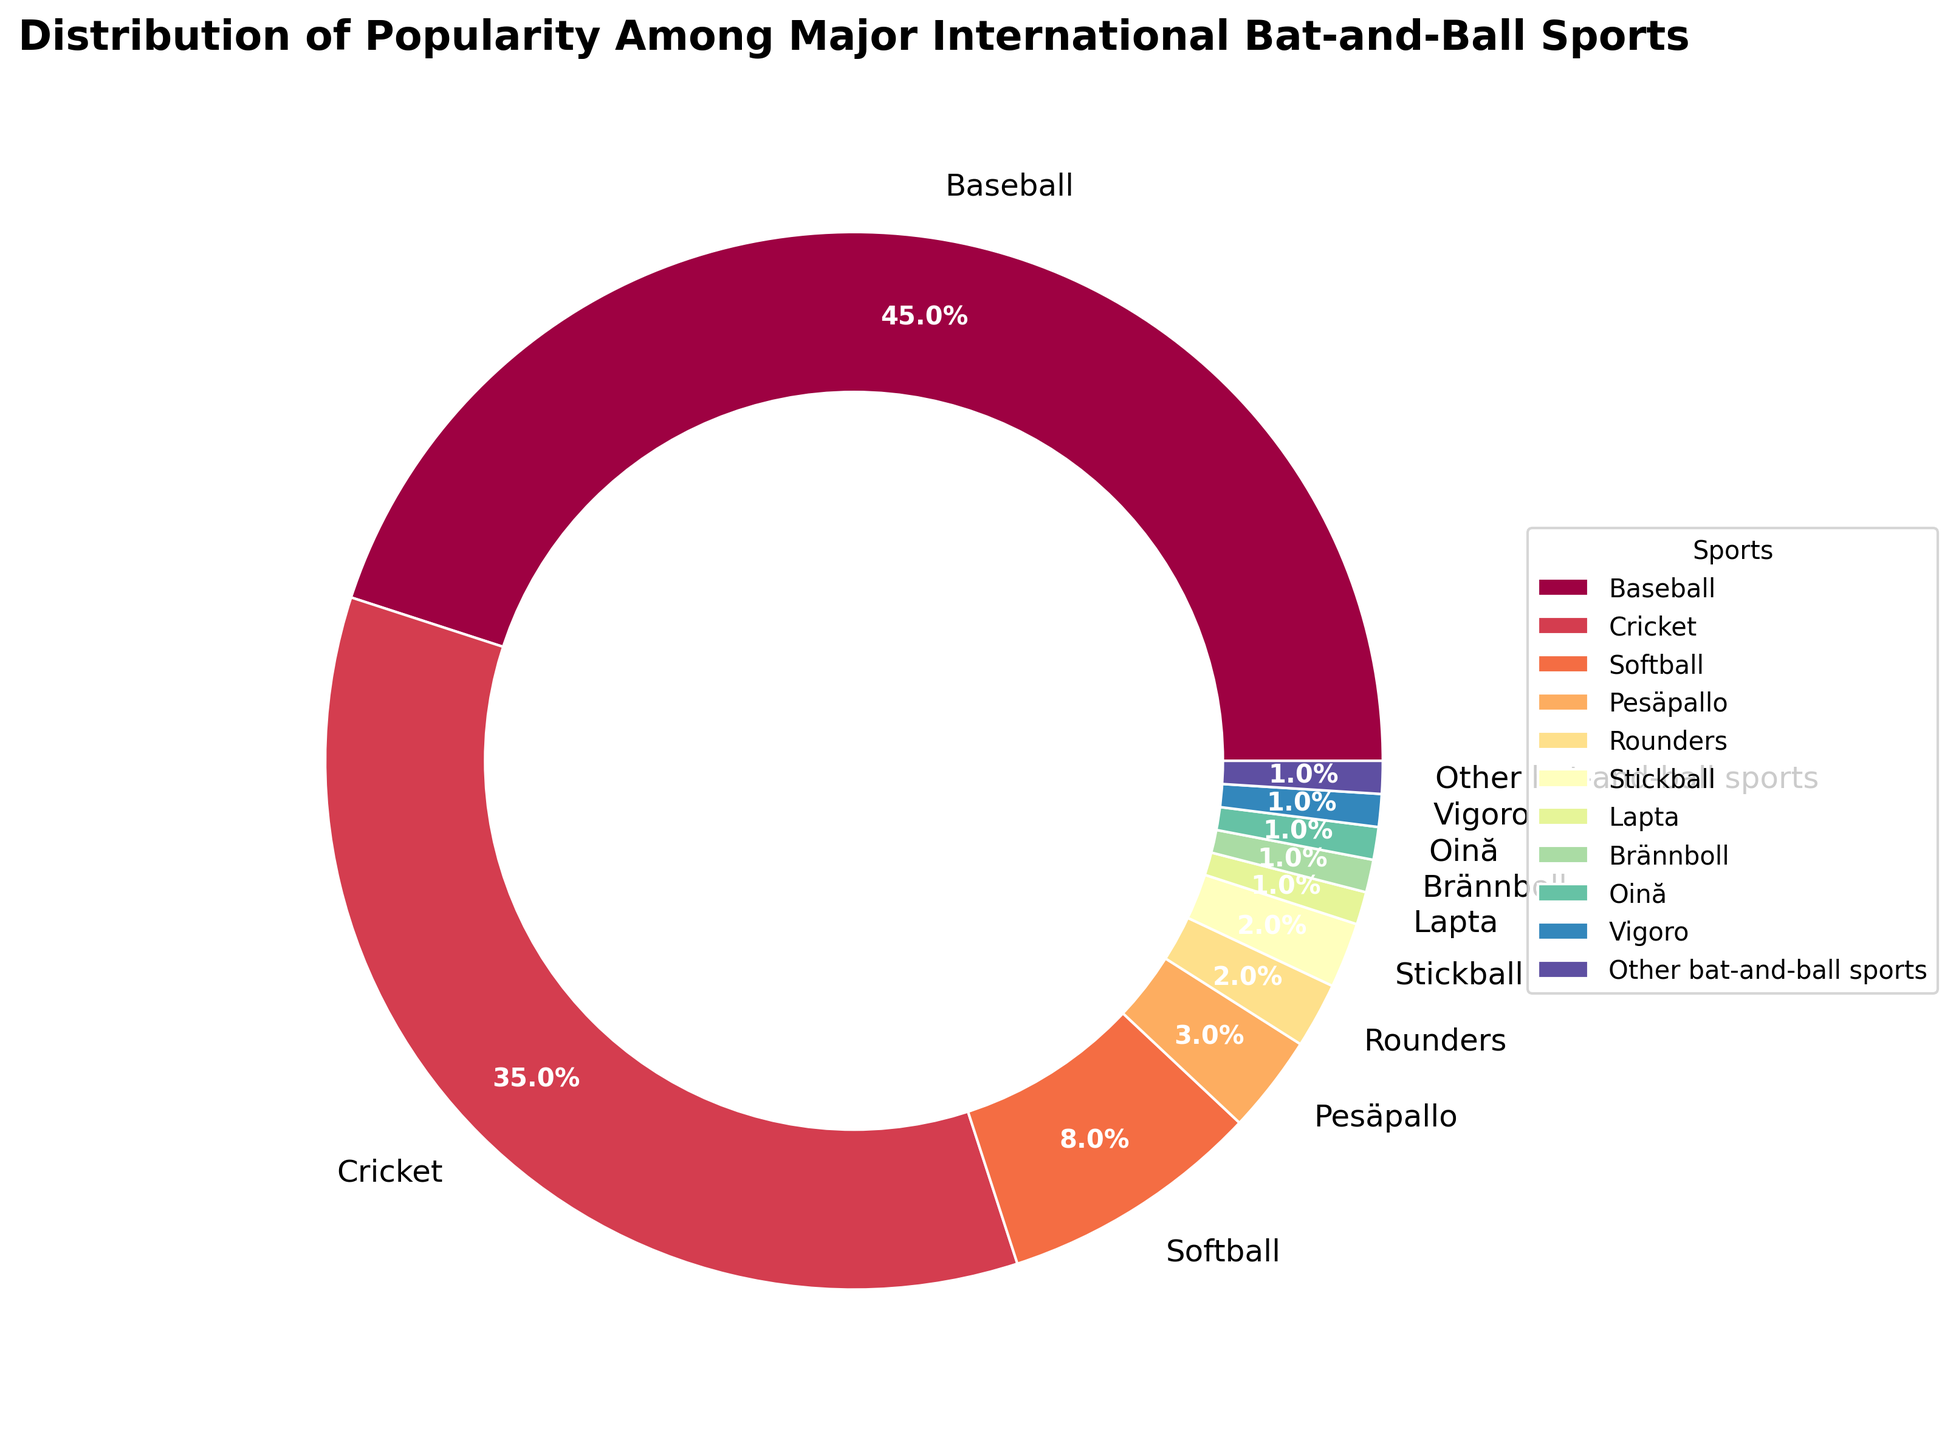Which sport has the highest popularity according to the pie chart? By looking at the size of the segments in the pie chart, the biggest segment represents Baseball.
Answer: Baseball Comparing Cricket and Softball, which sport is more popular? The pie chart shows that Cricket's segment is larger than Softball's segment. Therefore, Cricket is more popular than Softball.
Answer: Cricket What is the combined popularity percentage of Pesäpallo, Rounders, and Stickball? From the pie chart, we can see that Pesäpallo is 3%, Rounders is 2%, and Stickball is 2%. Summing these values, 3% + 2% + 2% = 7%.
Answer: 7% How does the popularity of Baseball compare to the total popularity of sports that each have a 1% share? Baseball has 45% popularity. The sports with 1% share are Lapta, Brännboll, Oină, Vigoro, and Other bat-and-ball sports, which collectively sum to 5%. So Baseball's popularity (45%) is greater than the combined popularity of these sports (5%).
Answer: Baseball's popularity is greater Which sport is represented by the smallest segment in the pie chart? The pie chart has several sports with the smallest segment, each at 1%. These sports are Lapta, Brännboll, Oină, Vigoro, and Other bat-and-ball sports.
Answer: Lapta, Brännboll, Oină, Vigoro, Other bat-and-ball sports What is the difference in popularity between Cricket and Softball? Cricket has 35% popularity, whereas Softball has 8% popularity. The difference is calculated as 35% - 8% = 27%.
Answer: 27% If you combine the popularity of all sports except Baseball, what is the total percentage? Baseball has 45% popularity. Therefore, the remaining sports collectively account for 100% - 45% = 55%.
Answer: 55% Which two sports combined have nearly the same popularity as Cricket alone? Cricket has 35% popularity. Combining Softball (8%) and Pesäpallo (3%) gives a total of 8% + 3% = 11%. Combining Softball (8%) and Rounders (2%) gives a total of 8% + 2% = 10%. However, combining Softball (8%) and Stickball (2%) gives 8% + 2% = 10%. This combination is still not close. Combining all lower percentages (Softball + Pesäpallo + Rounders + Stickball + Lapta + Brännboll + Oină + Vigoro + Other bat-and-ball sports) results in 8% + 3% + 2% + 2% + 1% + 1% + 1% + 1% + 1% = 20%. So, no two smaller sports combined equal Cricket's popularity. We need larger groups, but none equalize.
Answer: No combination equals exactly What is the average popularity percentage of all sports listed? There are 11 sports listed. Their total popularity sums up to 100% (since it's a pie chart representing the whole). So the average is 100% / 11 ≈ 9.09%.
Answer: ≈ 9.09% 